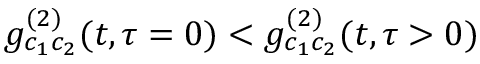<formula> <loc_0><loc_0><loc_500><loc_500>g _ { c _ { 1 } c _ { 2 } } ^ { ( 2 ) } ( t , \tau = 0 ) < g _ { c _ { 1 } c _ { 2 } } ^ { ( 2 ) } ( t , \tau > 0 )</formula> 